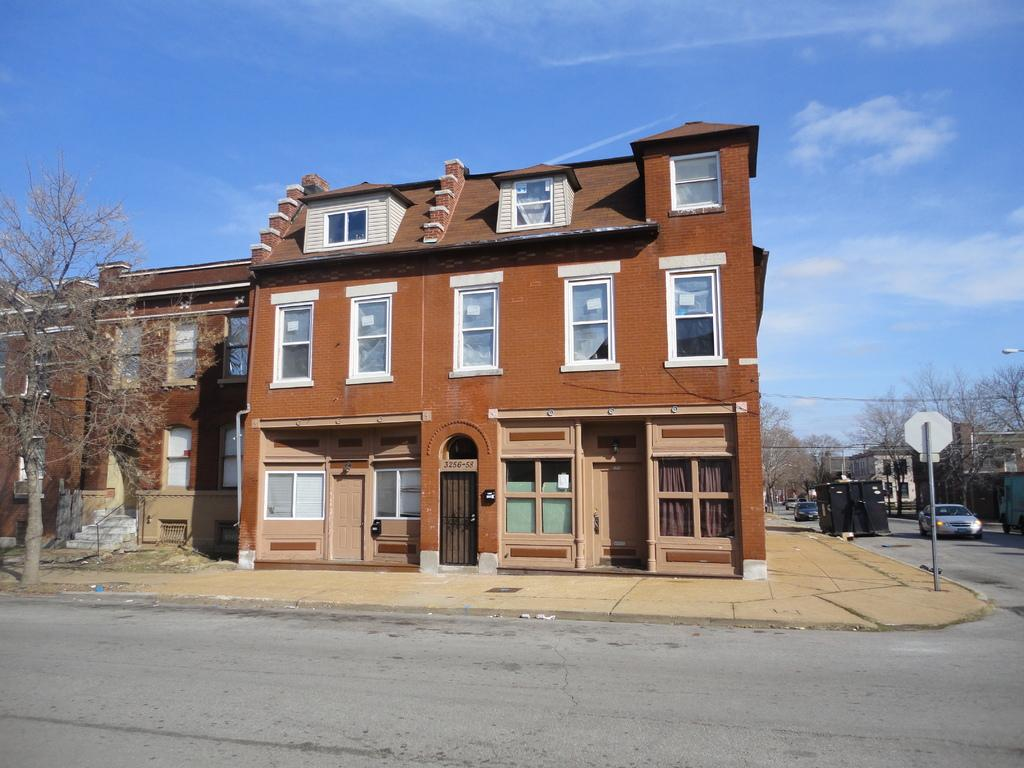What type of structures can be seen in the image? There are buildings in the image. What natural elements are present in the image? There are trees in the image. What architectural features can be observed in the buildings? There are windows, doors, and stairs in the image. What vehicles are visible in the image? There are cars in the image. What part of the natural environment is visible in the image? The sky is visible in the image, and there are clouds present. Can you see any magical creatures performing a spell in the image? There are no magical creatures or spells present in the image. Is there a bathtub visible in the image? There is no bathtub present in the image. 